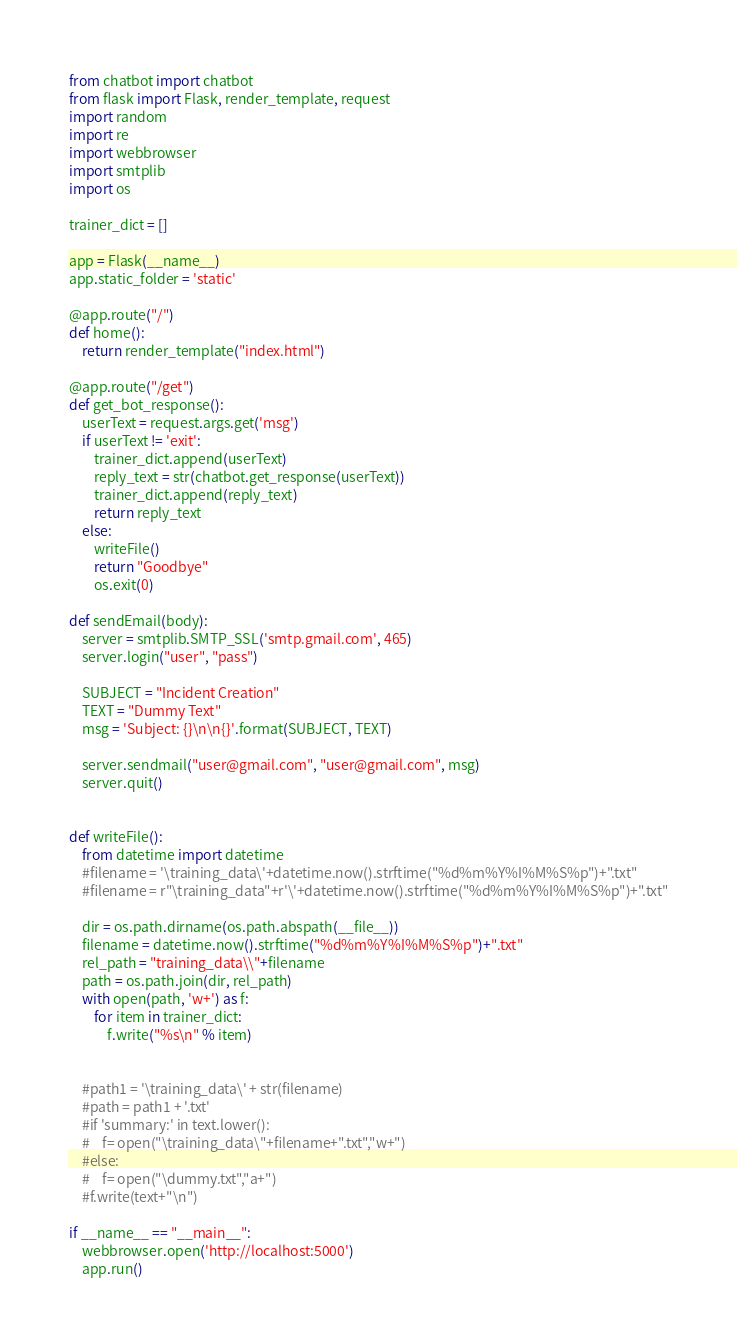<code> <loc_0><loc_0><loc_500><loc_500><_Python_>from chatbot import chatbot
from flask import Flask, render_template, request
import random
import re
import webbrowser
import smtplib
import os

trainer_dict = []

app = Flask(__name__)
app.static_folder = 'static'

@app.route("/")
def home():
    return render_template("index.html")

@app.route("/get")
def get_bot_response():
    userText = request.args.get('msg')
    if userText != 'exit':
        trainer_dict.append(userText)
        reply_text = str(chatbot.get_response(userText))
        trainer_dict.append(reply_text)
        return reply_text
    else:
        writeFile()
        return "Goodbye"
        os.exit(0)

def sendEmail(body):
    server = smtplib.SMTP_SSL('smtp.gmail.com', 465)
    server.login("user", "pass")

    SUBJECT = "Incident Creation"
    TEXT = "Dummy Text"
    msg = 'Subject: {}\n\n{}'.format(SUBJECT, TEXT)

    server.sendmail("user@gmail.com", "user@gmail.com", msg)
    server.quit()


def writeFile():
    from datetime import datetime
    #filename = '\training_data\'+datetime.now().strftime("%d%m%Y%I%M%S%p")+".txt"
    #filename = r"\training_data"+r'\'+datetime.now().strftime("%d%m%Y%I%M%S%p")+".txt"
    
    dir = os.path.dirname(os.path.abspath(__file__))
    filename = datetime.now().strftime("%d%m%Y%I%M%S%p")+".txt"
    rel_path = "training_data\\"+filename
    path = os.path.join(dir, rel_path)
    with open(path, 'w+') as f:
        for item in trainer_dict:
            f.write("%s\n" % item)
        
        
    #path1 = '\training_data\' + str(filename)
    #path = path1 + '.txt'
    #if 'summary:' in text.lower(): 
    #    f= open("\training_data\"+filename+".txt","w+")
    #else:   
    #    f= open("\dummy.txt","a+")
    #f.write(text+"\n")

if __name__ == "__main__":
    webbrowser.open('http://localhost:5000')
    app.run()
</code> 